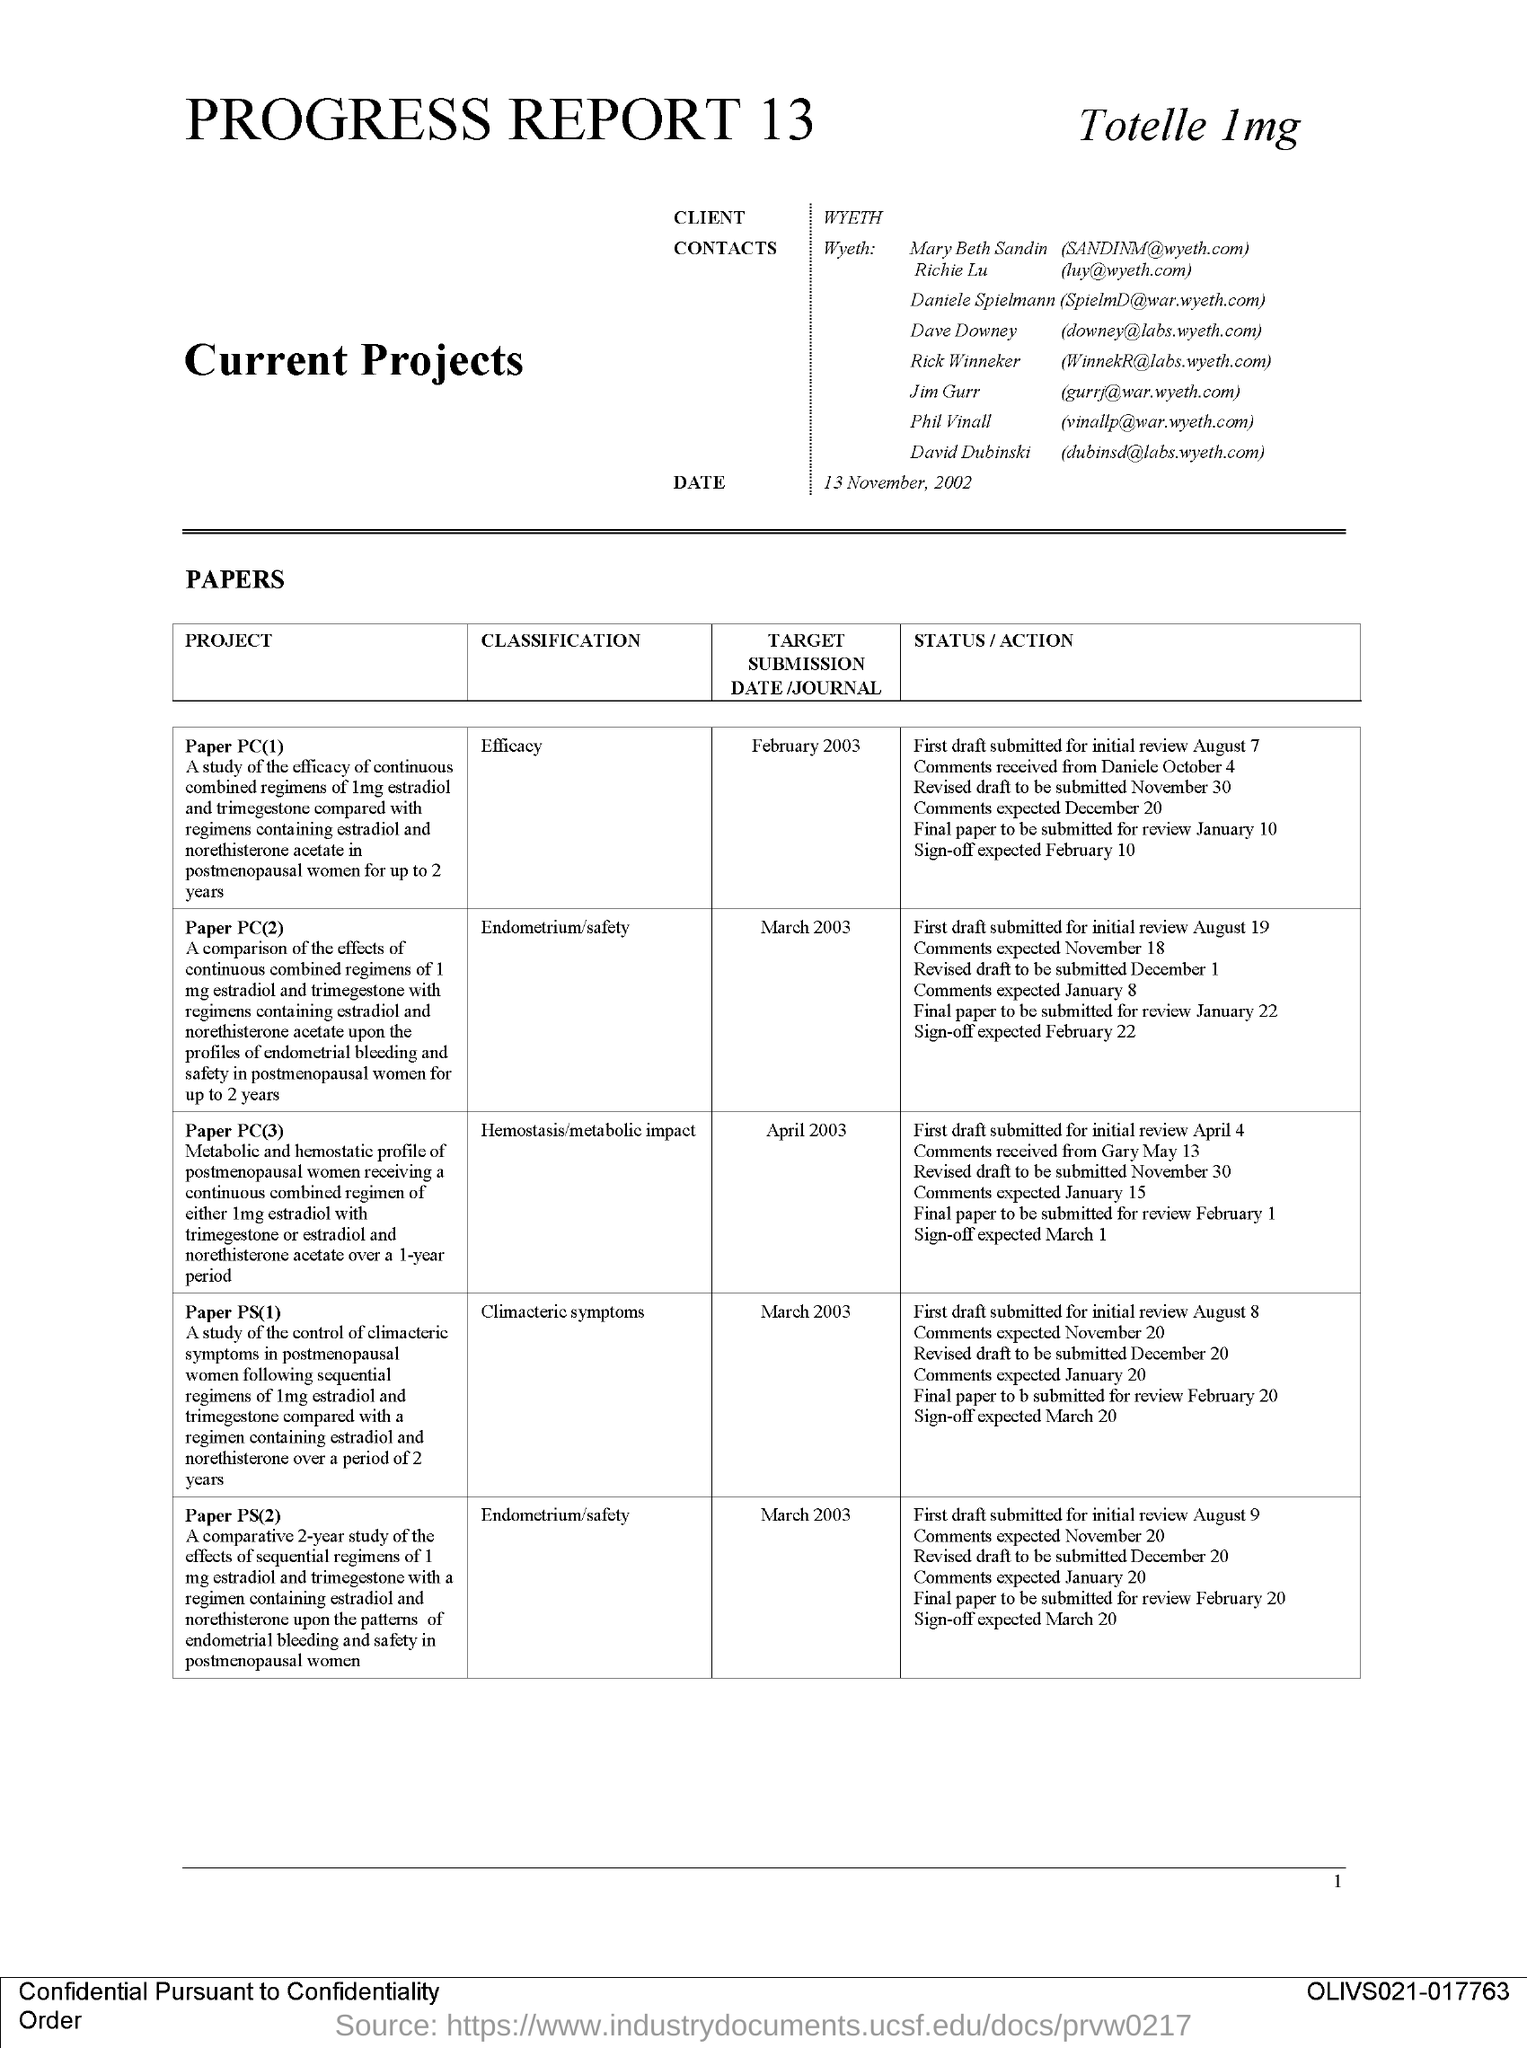What is the Page Number?
Ensure brevity in your answer.  1. When is the submission date of the project "Paper PC(1)"?
Make the answer very short. February 2003. "Paper PC(3)" belongs to which classification?
Your answer should be compact. Hemostasis/metabolic impact. "Paper PS(2)" belongs to which classification?
Offer a terse response. Endometrium/safety. "Paper PS(1)" belongs to which classification?
Provide a succinct answer. Climacteric symptoms. What is the name of the client?
Your response must be concise. Wyeth. 